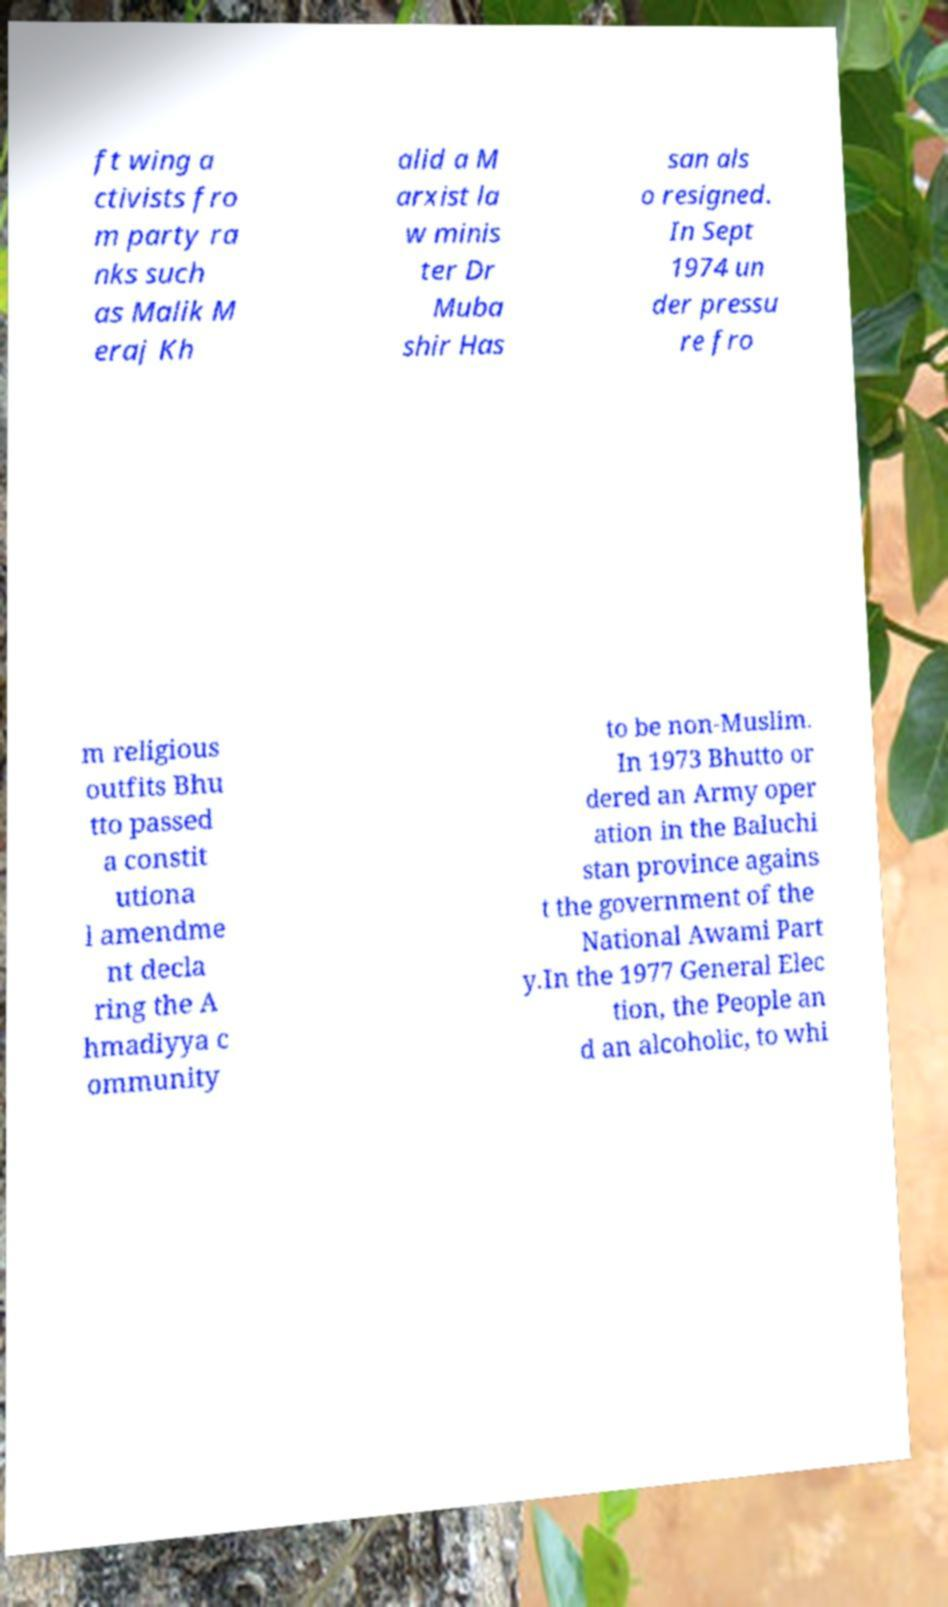Can you read and provide the text displayed in the image?This photo seems to have some interesting text. Can you extract and type it out for me? ft wing a ctivists fro m party ra nks such as Malik M eraj Kh alid a M arxist la w minis ter Dr Muba shir Has san als o resigned. In Sept 1974 un der pressu re fro m religious outfits Bhu tto passed a constit utiona l amendme nt decla ring the A hmadiyya c ommunity to be non-Muslim. In 1973 Bhutto or dered an Army oper ation in the Baluchi stan province agains t the government of the National Awami Part y.In the 1977 General Elec tion, the People an d an alcoholic, to whi 